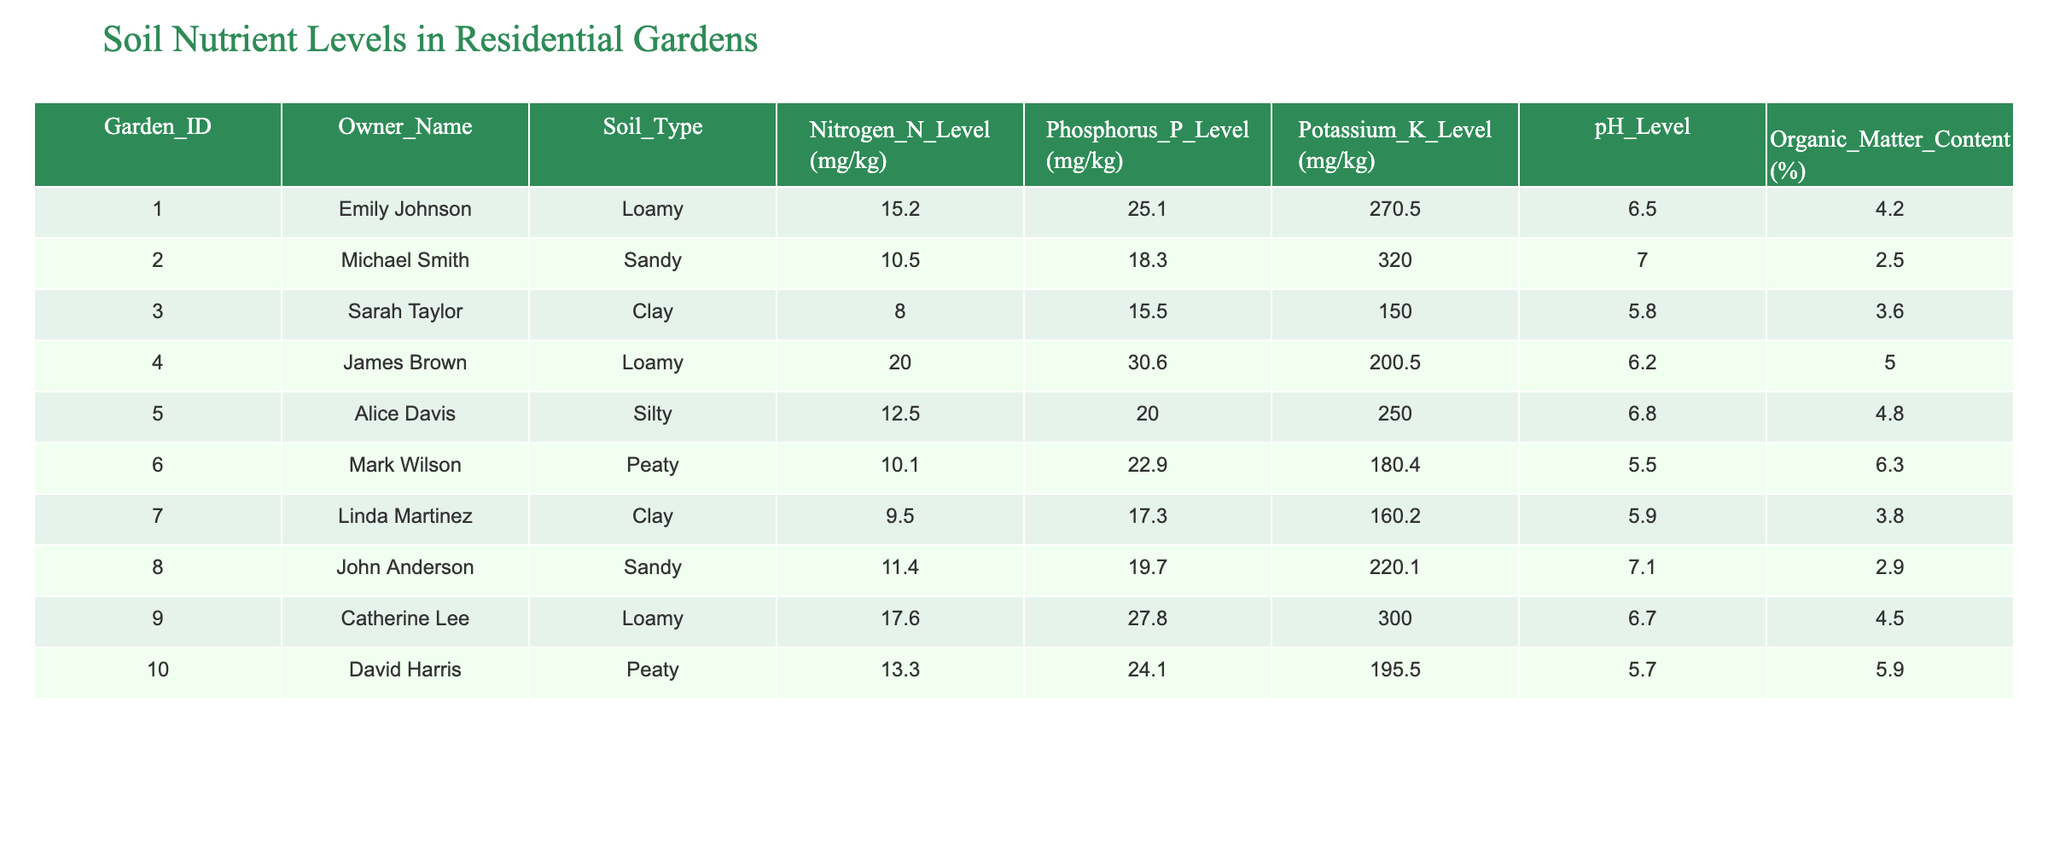What is the pH level of garden 4? The table shows the data for garden 4, which indicates a pH level of 6.2.
Answer: 6.2 Which garden has the highest nitrogen level? In the table, garden 4 has a nitrogen level of 20.0 mg/kg, which is higher than all other gardens listed.
Answer: Garden 4 Is the phosphorus level in garden 5 greater than in garden 3? The phosphorus level for garden 5 is 20.0 mg/kg, whereas garden 3 has 15.5 mg/kg. Since 20.0 is greater than 15.5, the statement is true.
Answer: Yes What is the average potassium level across all gardens? To find the average potassium level, sum the potassium levels from all gardens (270.5 + 320.0 + 150.0 + 200.5 + 250.0 + 180.4 + 160.2 + 220.1 + 300.0 + 195.5) = 1958.2 mg/kg. Then divide by the number of gardens (10), which gives 195.82 mg/kg.
Answer: 195.82 Which type of soil has the highest average organic matter content? To find the soil type with the highest average organic matter content, we can group the data by soil type and calculate the average for each. For loamy: (4.2 + 4.5)/2 = 4.35%, sandy: (2.5 + 2.9)/2 = 2.7%, clay: (3.6 + 3.8)/2 = 3.7%, silty: 4.8%, peaty: (6.3 + 5.9)/2 = 6.1%. Peaty soil has the highest average at 6.1%.
Answer: Peaty Does garden 9 have a higher nitrogen level than garden 7? The nitrogen level for garden 9 is 17.6 mg/kg while garden 7's is 9.5 mg/kg. Since 17.6 is greater than 9.5, the statement is true.
Answer: Yes What is the difference between the highest and lowest pH levels in the gardens? The highest pH level is found in sandy garden 2 at 7.0, while the lowest is in clay garden 3 at 5.8. To find the difference, calculate 7.0 - 5.8 = 1.2.
Answer: 1.2 How many gardens have organic matter content above 4%? From the table, gardens with organic matter content above 4% are garden 1 (4.2%), garden 4 (5.0%), garden 5 (4.8%), and garden 10 (5.9%). Thus, there are 4 gardens.
Answer: 4 Is the nitrogen level in garden 6 less than 15 mg/kg? The nitrogen level for garden 6 is 10.1 mg/kg, which is indeed less than 15 mg/kg. Therefore, the statement is true.
Answer: Yes 